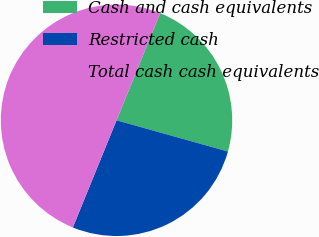<chart> <loc_0><loc_0><loc_500><loc_500><pie_chart><fcel>Cash and cash equivalents<fcel>Restricted cash<fcel>Total cash cash equivalents<nl><fcel>23.19%<fcel>26.81%<fcel>50.0%<nl></chart> 